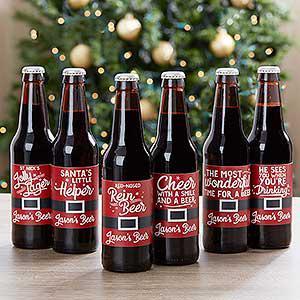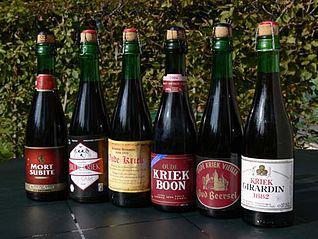The first image is the image on the left, the second image is the image on the right. For the images shown, is this caption "There are multiple of the same bottles next to each other." true? Answer yes or no. Yes. The first image is the image on the left, the second image is the image on the right. For the images shown, is this caption "The left and right image contains the same number of glass drinking bottles." true? Answer yes or no. Yes. 